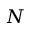Convert formula to latex. <formula><loc_0><loc_0><loc_500><loc_500>N</formula> 